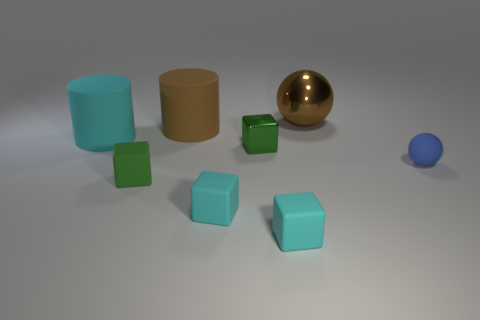Subtract all tiny green rubber cubes. How many cubes are left? 3 Subtract 1 cylinders. How many cylinders are left? 1 Add 1 tiny cyan objects. How many objects exist? 9 Subtract all green things. Subtract all big brown objects. How many objects are left? 4 Add 6 blue rubber objects. How many blue rubber objects are left? 7 Add 7 small green objects. How many small green objects exist? 9 Subtract all green cubes. How many cubes are left? 2 Subtract 2 green blocks. How many objects are left? 6 Subtract all cylinders. How many objects are left? 6 Subtract all brown balls. Subtract all yellow cylinders. How many balls are left? 1 